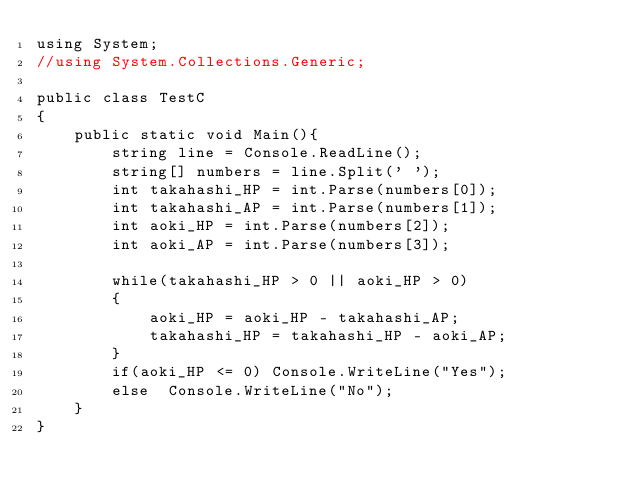Convert code to text. <code><loc_0><loc_0><loc_500><loc_500><_C#_>using System;
//using System.Collections.Generic;

public class TestC
{
    public static void Main(){
        string line = Console.ReadLine();
        string[] numbers = line.Split(' ');
        int takahashi_HP = int.Parse(numbers[0]);
        int takahashi_AP = int.Parse(numbers[1]); 
        int aoki_HP = int.Parse(numbers[2]);
        int aoki_AP = int.Parse(numbers[3]); 

        while(takahashi_HP > 0 || aoki_HP > 0)
        {
            aoki_HP = aoki_HP - takahashi_AP;
            takahashi_HP = takahashi_HP - aoki_AP;
        }
        if(aoki_HP <= 0) Console.WriteLine("Yes");
        else  Console.WriteLine("No");
    }
}</code> 